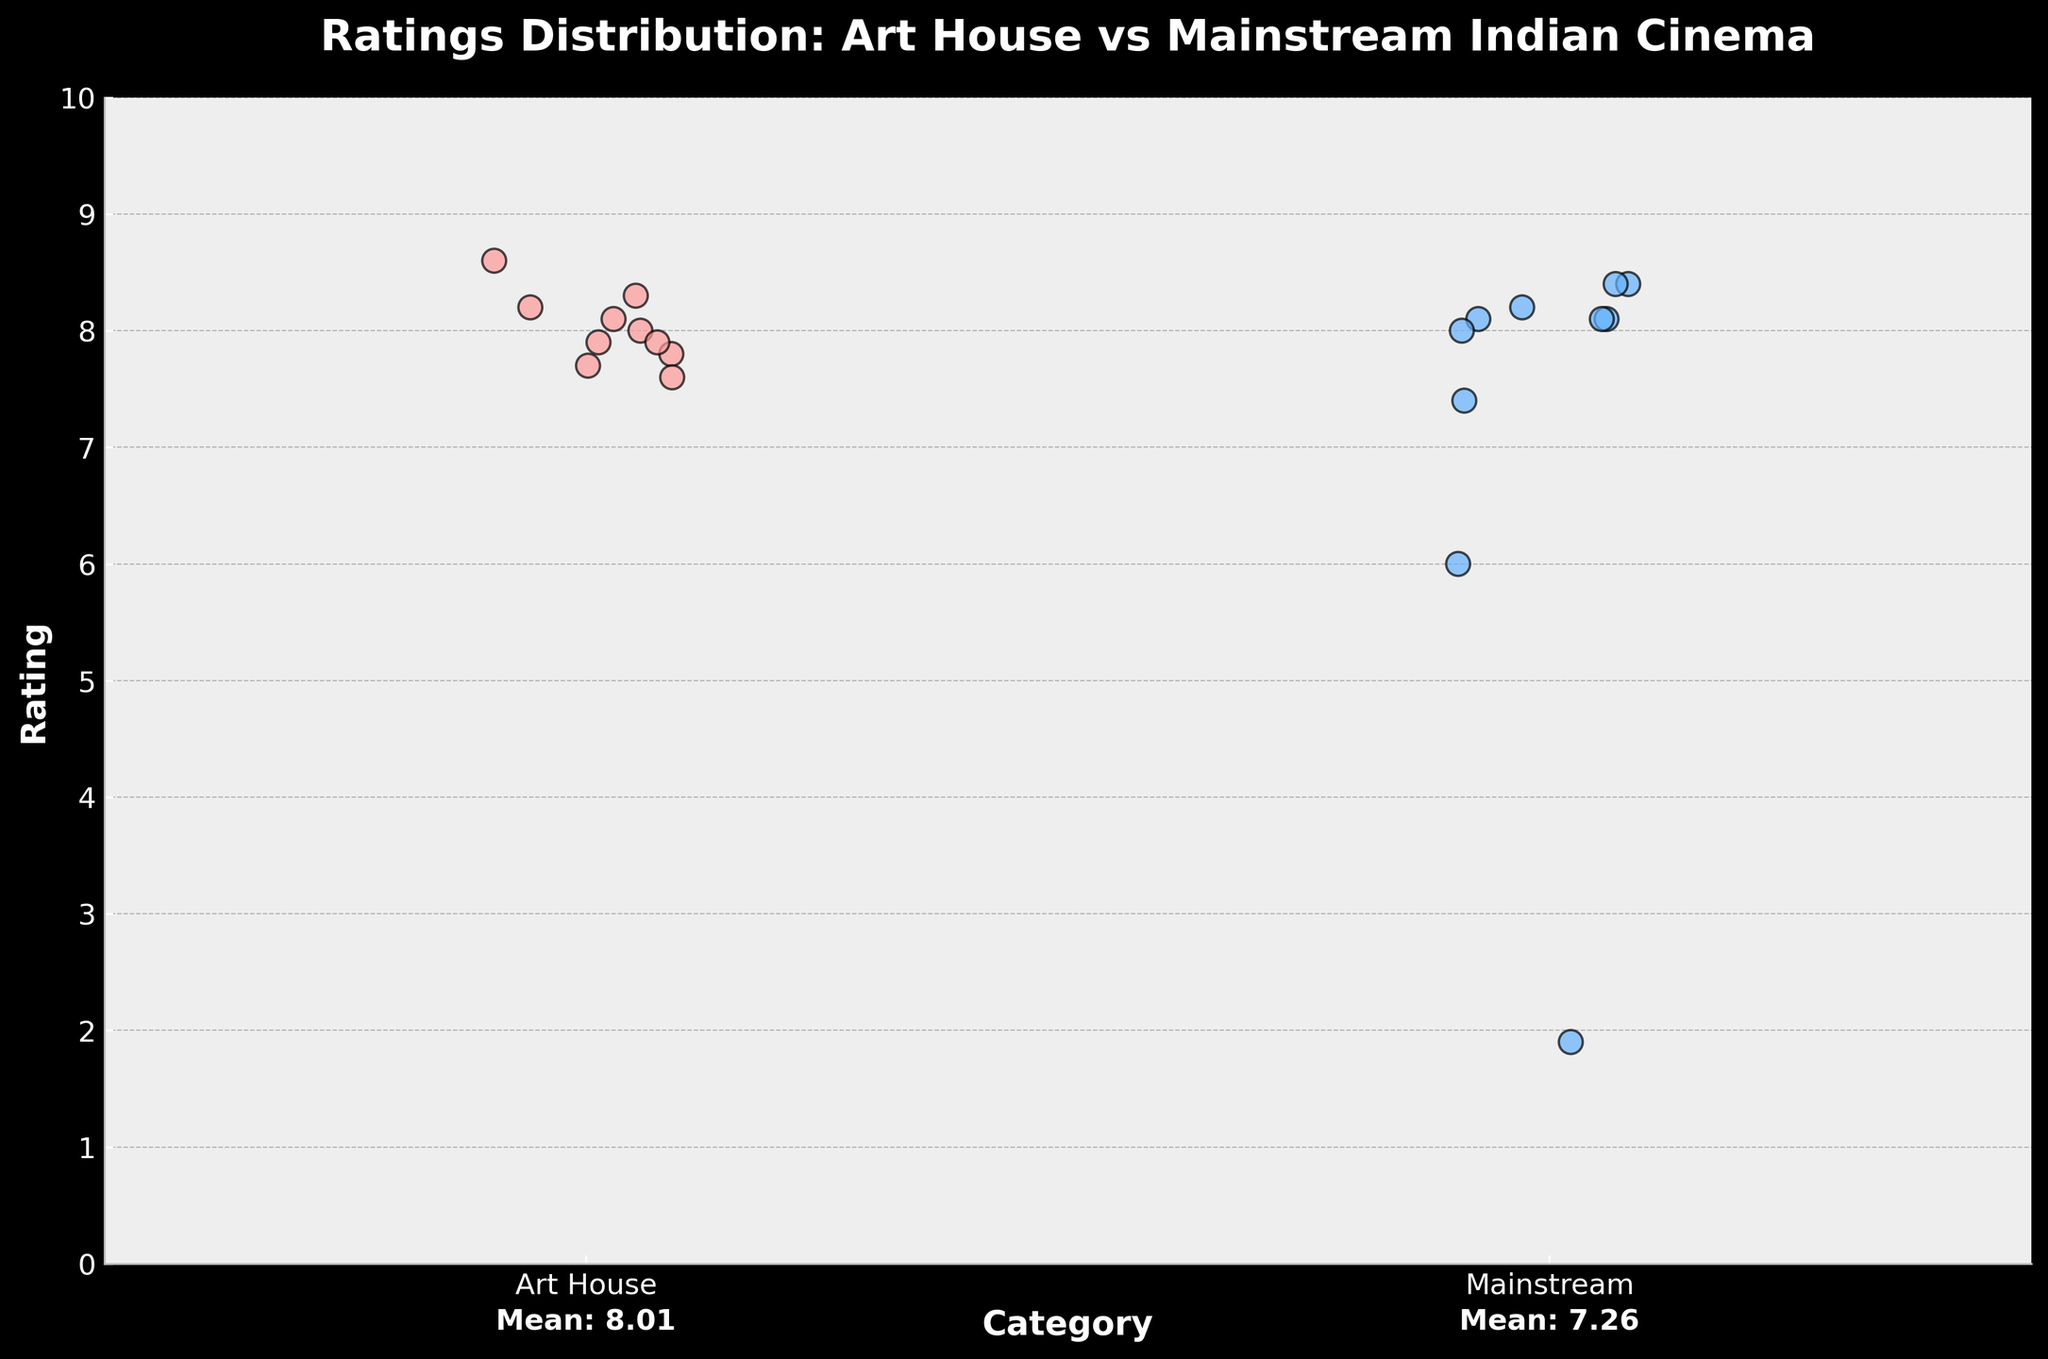What's the title of the figure? The title is located at the top of the figure in bold font. It provides an overview of what the figure is about.
Answer: Ratings Distribution: Art House vs Mainstream Indian Cinema What are the categories represented on the x-axis? The x-axis, labeled as 'Category,' differentiates the two types of cinema. The category names are listed below the axis.
Answer: Art House, Mainstream What is the range of ratings shown on the y-axis? The y-axis, labeled as 'Rating,' shows a numerical scale with tick marks. Reading from bottom to top indicates the range.
Answer: 0 to 10 How many movies are represented in the 'Mainstream' category? By counting the individual points on the strip plot under the 'Mainstream' category, the number of data points can be determined.
Answer: 10 Which category has the highest-rated movie and what is its rating? Locate the highest point on the y-axis and identify which category it belongs to by following the corresponding data point.
Answer: Art House (Jaane Bhi Do Yaaro, 8.6) What is the mean rating for Art House movies? The mean rating is written below the 'Art House' category on the x-axis. No calculations are required.
Answer: 8.05 What is the difference between the highest and lowest ratings in the Mainstream category? Identify the highest and lowest points in the 'Mainstream' category and calculate the difference. Highest is 8.4, lowest is 1.9. The difference is 8.4 - 1.9.
Answer: 6.5 How do the mean ratings compare between the two categories? Check the mean ratings provided below each category on the x-axis. Compare the two values. Art House has a mean of 8.05, and Mainstream has a mean of 7.26.
Answer: Art House has a higher mean rating than Mainstream What unique feature can you observe in the Mainstream category's data distribution? Examine the spread, outliers, and any distinct patterns in the Mainstream category's strip plot. Note the presence of an extremely low outlier.
Answer: There is one extremely low-rated movie (Race 3, 1.9) Which category shows a more consistent rating distribution? Observe the clustering of points within each category. Art House movies are tightly clustered indicating consistency, while Mainstream movies show more spread.
Answer: Art House 